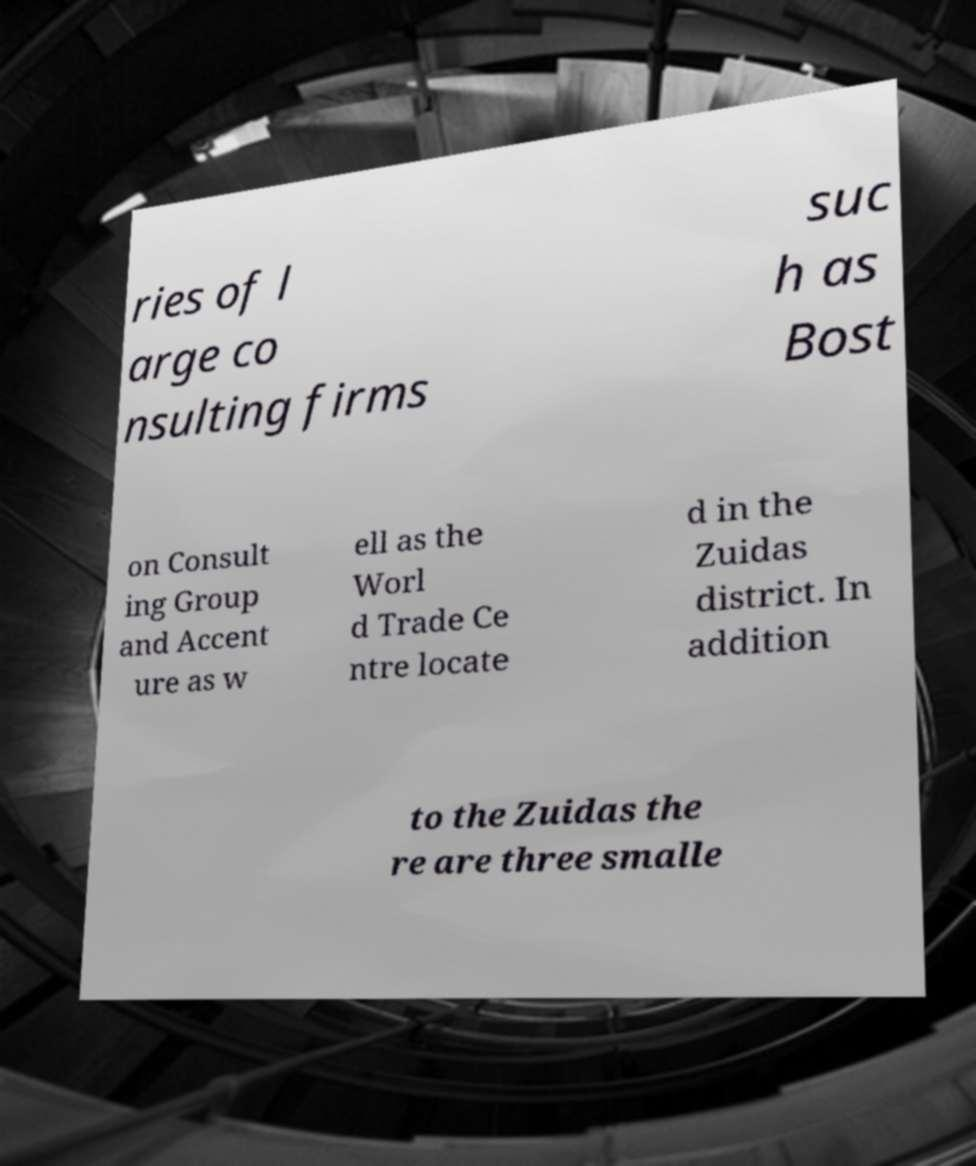For documentation purposes, I need the text within this image transcribed. Could you provide that? ries of l arge co nsulting firms suc h as Bost on Consult ing Group and Accent ure as w ell as the Worl d Trade Ce ntre locate d in the Zuidas district. In addition to the Zuidas the re are three smalle 